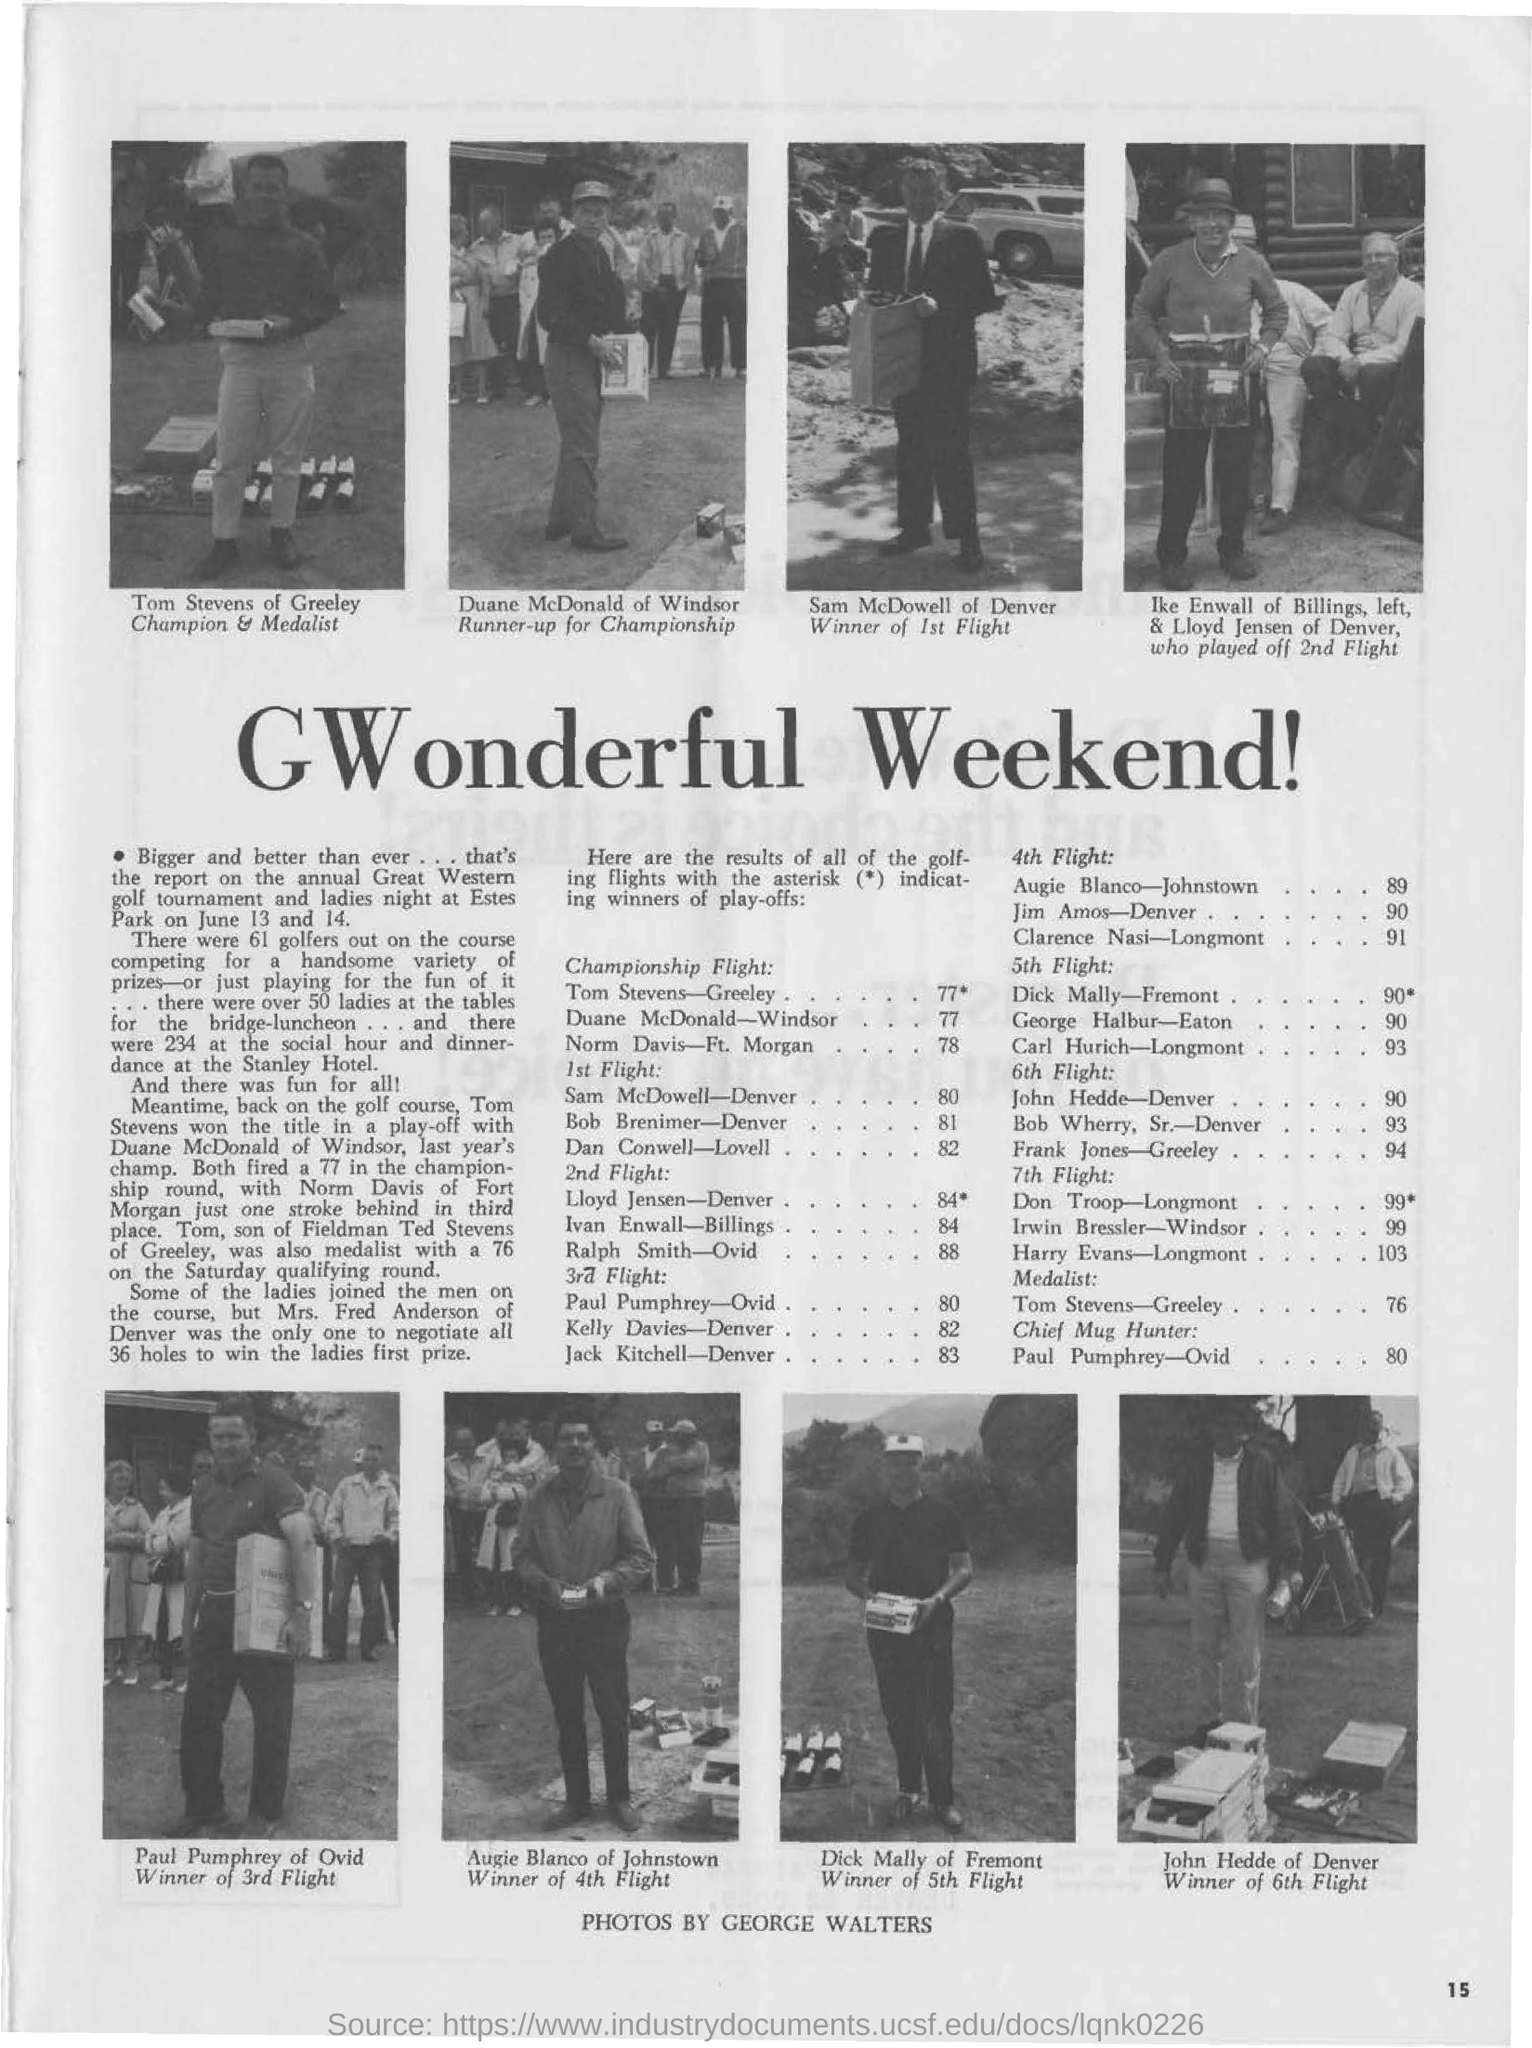Indicate a few pertinent items in this graphic. Sam McDowell from Denver is the winner of the 1st flight. The document's title is 'GWonderful Weekend!' The individual known as Tom Stevens is originally from the location of Greeley, Tom Stevens of Greeley is the champion. 